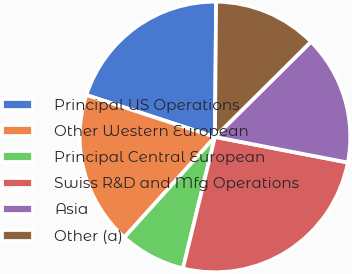Convert chart. <chart><loc_0><loc_0><loc_500><loc_500><pie_chart><fcel>Principal US Operations<fcel>Other Western European<fcel>Principal Central European<fcel>Swiss R&D and Mfg Operations<fcel>Asia<fcel>Other (a)<nl><fcel>20.12%<fcel>18.33%<fcel>7.88%<fcel>25.78%<fcel>15.46%<fcel>12.43%<nl></chart> 